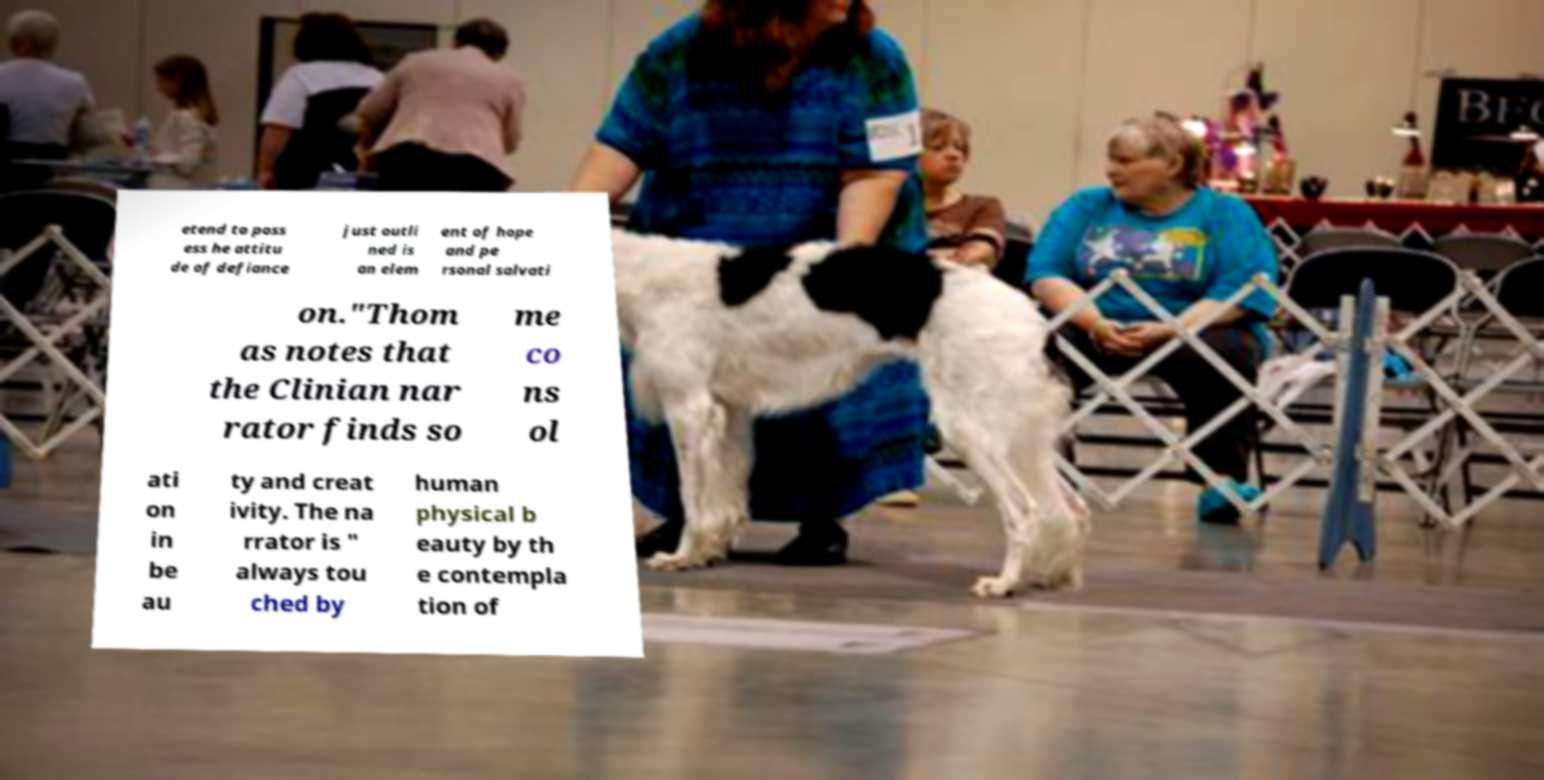For documentation purposes, I need the text within this image transcribed. Could you provide that? etend to poss ess he attitu de of defiance just outli ned is an elem ent of hope and pe rsonal salvati on."Thom as notes that the Clinian nar rator finds so me co ns ol ati on in be au ty and creat ivity. The na rrator is " always tou ched by human physical b eauty by th e contempla tion of 